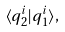Convert formula to latex. <formula><loc_0><loc_0><loc_500><loc_500>\langle q ^ { i } _ { 2 } | q ^ { i } _ { 1 } \rangle ,</formula> 